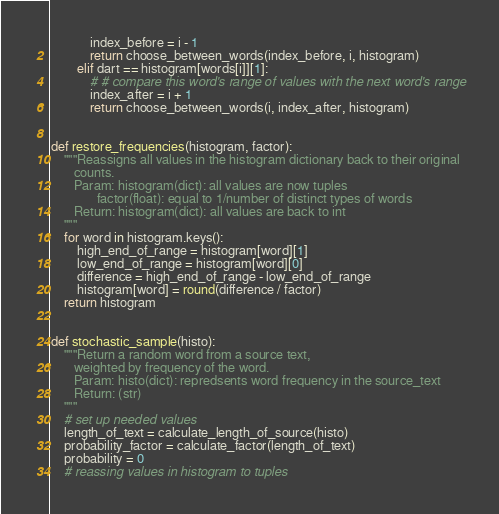<code> <loc_0><loc_0><loc_500><loc_500><_Python_>            index_before = i - 1
            return choose_between_words(index_before, i, histogram)
        elif dart == histogram[words[i]][1]:
            # # compare this word's range of values with the next word's range
            index_after = i + 1
            return choose_between_words(i, index_after, histogram)


def restore_frequencies(histogram, factor):
    """Reassigns all values in the histogram dictionary back to their original
       counts.
       Param: histogram(dict): all values are now tuples
              factor(float): equal to 1/number of distinct types of words
       Return: histogram(dict): all values are back to int
    """
    for word in histogram.keys():
        high_end_of_range = histogram[word][1]
        low_end_of_range = histogram[word][0]
        difference = high_end_of_range - low_end_of_range
        histogram[word] = round(difference / factor)
    return histogram


def stochastic_sample(histo):
    """Return a random word from a source text,
       weighted by frequency of the word.
       Param: histo(dict): repredsents word frequency in the source_text
       Return: (str)
    """
    # set up needed values
    length_of_text = calculate_length_of_source(histo)
    probability_factor = calculate_factor(length_of_text)
    probability = 0
    # reassing values in histogram to tuples</code> 